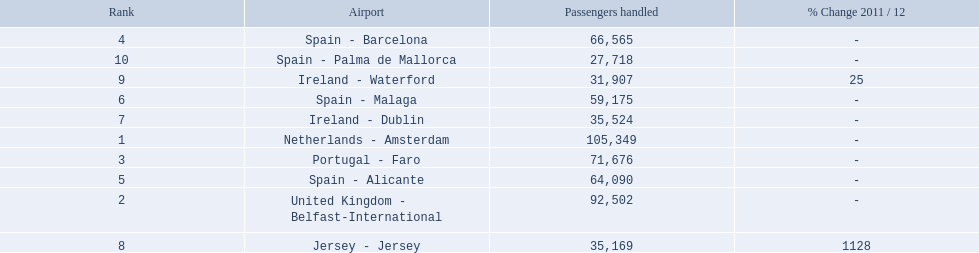What are all the passengers handled values for london southend airport? 105,349, 92,502, 71,676, 66,565, 64,090, 59,175, 35,524, 35,169, 31,907, 27,718. Which are 30,000 or less? 27,718. What airport is this for? Spain - Palma de Mallorca. 